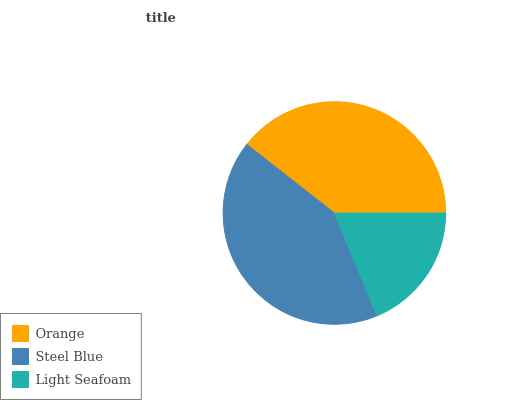Is Light Seafoam the minimum?
Answer yes or no. Yes. Is Steel Blue the maximum?
Answer yes or no. Yes. Is Steel Blue the minimum?
Answer yes or no. No. Is Light Seafoam the maximum?
Answer yes or no. No. Is Steel Blue greater than Light Seafoam?
Answer yes or no. Yes. Is Light Seafoam less than Steel Blue?
Answer yes or no. Yes. Is Light Seafoam greater than Steel Blue?
Answer yes or no. No. Is Steel Blue less than Light Seafoam?
Answer yes or no. No. Is Orange the high median?
Answer yes or no. Yes. Is Orange the low median?
Answer yes or no. Yes. Is Light Seafoam the high median?
Answer yes or no. No. Is Light Seafoam the low median?
Answer yes or no. No. 